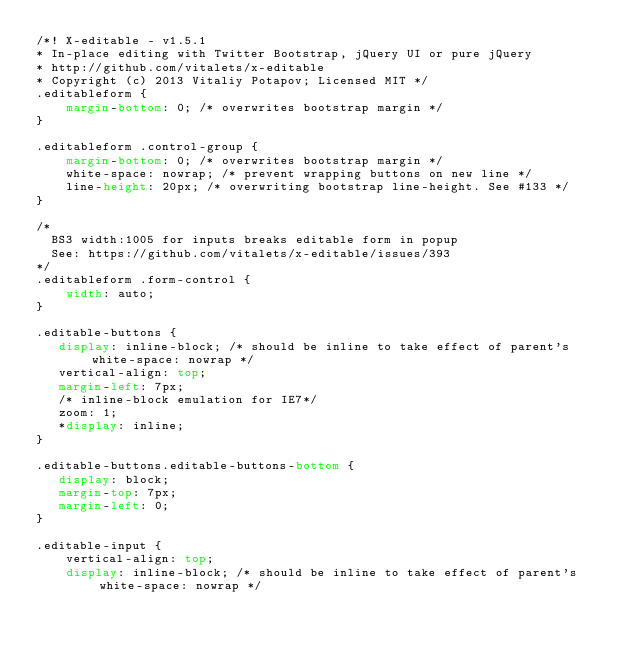<code> <loc_0><loc_0><loc_500><loc_500><_CSS_>/*! X-editable - v1.5.1 
* In-place editing with Twitter Bootstrap, jQuery UI or pure jQuery
* http://github.com/vitalets/x-editable
* Copyright (c) 2013 Vitaliy Potapov; Licensed MIT */
.editableform {
    margin-bottom: 0; /* overwrites bootstrap margin */
}

.editableform .control-group {
    margin-bottom: 0; /* overwrites bootstrap margin */
    white-space: nowrap; /* prevent wrapping buttons on new line */
    line-height: 20px; /* overwriting bootstrap line-height. See #133 */
}

/* 
  BS3 width:1005 for inputs breaks editable form in popup 
  See: https://github.com/vitalets/x-editable/issues/393
*/
.editableform .form-control {
    width: auto;
}

.editable-buttons {
   display: inline-block; /* should be inline to take effect of parent's white-space: nowrap */
   vertical-align: top;
   margin-left: 7px;
   /* inline-block emulation for IE7*/
   zoom: 1; 
   *display: inline;
}

.editable-buttons.editable-buttons-bottom {
   display: block; 
   margin-top: 7px;
   margin-left: 0;
}

.editable-input {
    vertical-align: top; 
    display: inline-block; /* should be inline to take effect of parent's white-space: nowrap */</code> 